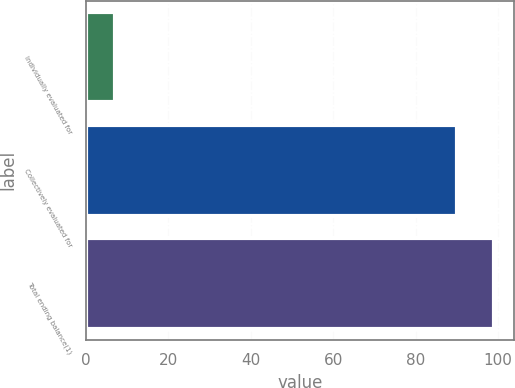<chart> <loc_0><loc_0><loc_500><loc_500><bar_chart><fcel>Individually evaluated for<fcel>Collectively evaluated for<fcel>Total ending balance(1)<nl><fcel>7<fcel>90<fcel>99<nl></chart> 